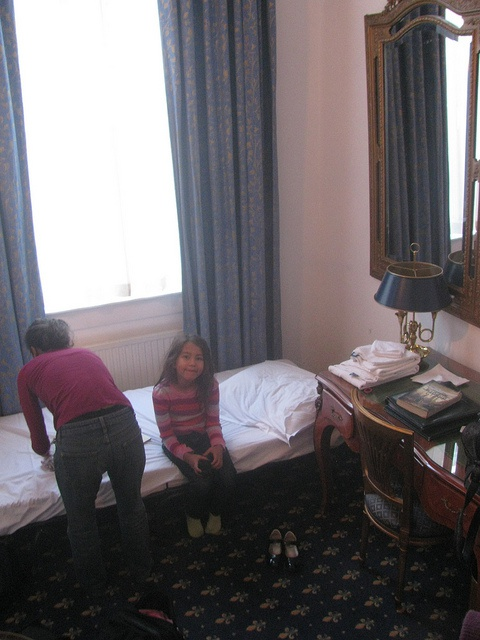Describe the objects in this image and their specific colors. I can see people in gray, black, and purple tones, bed in gray, darkgray, and lavender tones, chair in gray, black, and maroon tones, people in gray, black, brown, purple, and maroon tones, and book in gray, darkgray, and black tones in this image. 